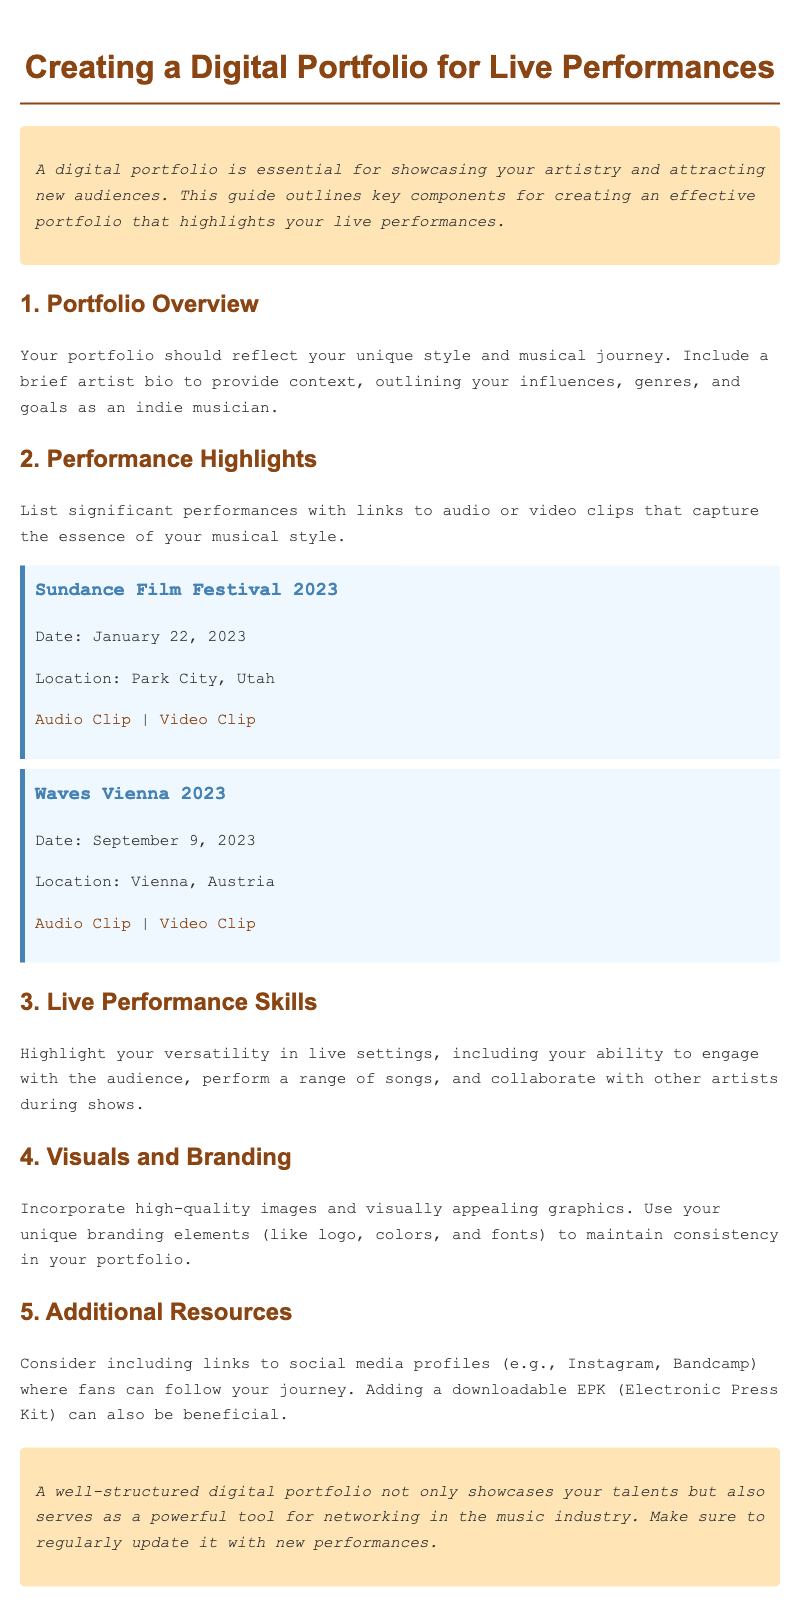What is the title of the document? The title clearly states the topic of the guide, which is "Creating a Digital Portfolio for Live Performances."
Answer: Creating a Digital Portfolio for Live Performances What is included in the Performance Highlights section? This section lists significant performances along with links to audio or video clips.
Answer: Significant performances with links to audio or video clips When did the Sundance Film Festival performance take place? The performance date is specified in the document as January 22, 2023.
Answer: January 22, 2023 Where was the Waves Vienna 2023 performance held? The document mentions the location of the performance as Vienna, Austria.
Answer: Vienna, Austria What type of skills does the Live Performance Skills section emphasize? This section emphasizes versatility in engaging with the audience, performing songs, and collaborating with other artists.
Answer: Versatility in live settings Which components should be included in the Additional Resources section? This section suggests including links to social media profiles and a downloadable EPK.
Answer: Links to social media profiles and a downloadable EPK What background color is used for the intro and conclusion? The intro and conclusion sections have a background color specified as #ffe4b5.
Answer: #ffe4b5 What is the recommended action for maintaining the portfolio? The conclusion advises to regularly update the portfolio with new performances.
Answer: Regularly update it with new performances 